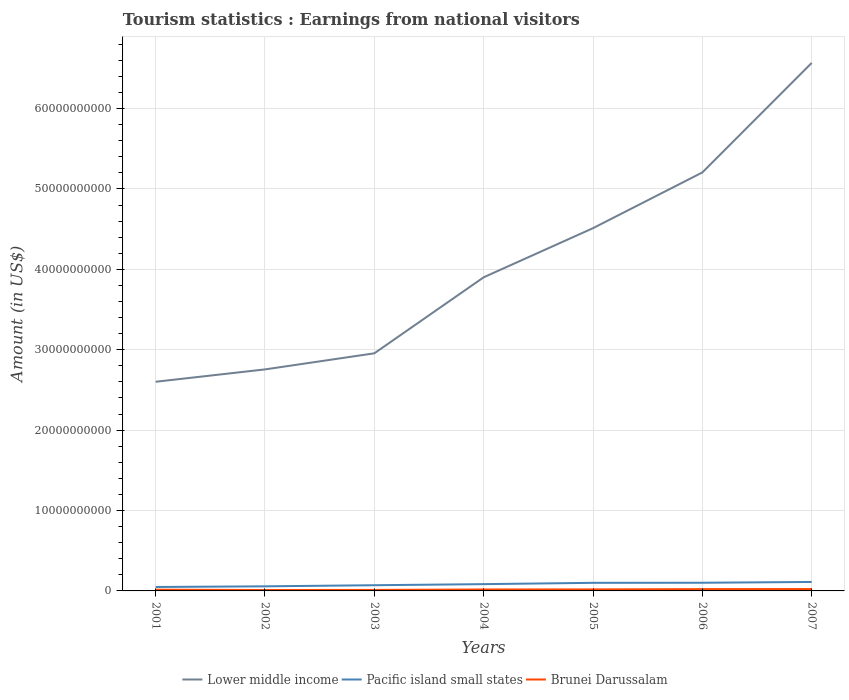How many different coloured lines are there?
Your answer should be compact. 3. Is the number of lines equal to the number of legend labels?
Keep it short and to the point. Yes. Across all years, what is the maximum earnings from national visitors in Brunei Darussalam?
Make the answer very short. 1.13e+08. In which year was the earnings from national visitors in Brunei Darussalam maximum?
Offer a terse response. 2002. What is the total earnings from national visitors in Lower middle income in the graph?
Offer a very short reply. -2.06e+1. What is the difference between the highest and the second highest earnings from national visitors in Lower middle income?
Your response must be concise. 3.97e+1. Is the earnings from national visitors in Lower middle income strictly greater than the earnings from national visitors in Pacific island small states over the years?
Your answer should be compact. No. How many years are there in the graph?
Your answer should be compact. 7. What is the difference between two consecutive major ticks on the Y-axis?
Make the answer very short. 1.00e+1. Are the values on the major ticks of Y-axis written in scientific E-notation?
Make the answer very short. No. Does the graph contain any zero values?
Provide a short and direct response. No. How many legend labels are there?
Make the answer very short. 3. What is the title of the graph?
Your answer should be very brief. Tourism statistics : Earnings from national visitors. What is the label or title of the Y-axis?
Give a very brief answer. Amount (in US$). What is the Amount (in US$) of Lower middle income in 2001?
Ensure brevity in your answer.  2.60e+1. What is the Amount (in US$) in Pacific island small states in 2001?
Offer a terse response. 4.90e+08. What is the Amount (in US$) in Brunei Darussalam in 2001?
Give a very brief answer. 1.55e+08. What is the Amount (in US$) of Lower middle income in 2002?
Offer a very short reply. 2.76e+1. What is the Amount (in US$) of Pacific island small states in 2002?
Your response must be concise. 5.71e+08. What is the Amount (in US$) in Brunei Darussalam in 2002?
Offer a very short reply. 1.13e+08. What is the Amount (in US$) in Lower middle income in 2003?
Give a very brief answer. 2.96e+1. What is the Amount (in US$) in Pacific island small states in 2003?
Your answer should be compact. 7.10e+08. What is the Amount (in US$) of Brunei Darussalam in 2003?
Provide a short and direct response. 1.24e+08. What is the Amount (in US$) in Lower middle income in 2004?
Provide a short and direct response. 3.90e+1. What is the Amount (in US$) of Pacific island small states in 2004?
Offer a terse response. 8.44e+08. What is the Amount (in US$) of Brunei Darussalam in 2004?
Give a very brief answer. 1.81e+08. What is the Amount (in US$) in Lower middle income in 2005?
Ensure brevity in your answer.  4.51e+1. What is the Amount (in US$) of Pacific island small states in 2005?
Your answer should be very brief. 1.01e+09. What is the Amount (in US$) of Brunei Darussalam in 2005?
Offer a terse response. 1.91e+08. What is the Amount (in US$) of Lower middle income in 2006?
Your answer should be very brief. 5.21e+1. What is the Amount (in US$) of Pacific island small states in 2006?
Your answer should be very brief. 1.02e+09. What is the Amount (in US$) in Brunei Darussalam in 2006?
Make the answer very short. 2.24e+08. What is the Amount (in US$) in Lower middle income in 2007?
Keep it short and to the point. 6.57e+1. What is the Amount (in US$) in Pacific island small states in 2007?
Your response must be concise. 1.12e+09. What is the Amount (in US$) of Brunei Darussalam in 2007?
Keep it short and to the point. 2.33e+08. Across all years, what is the maximum Amount (in US$) of Lower middle income?
Make the answer very short. 6.57e+1. Across all years, what is the maximum Amount (in US$) of Pacific island small states?
Provide a succinct answer. 1.12e+09. Across all years, what is the maximum Amount (in US$) in Brunei Darussalam?
Your response must be concise. 2.33e+08. Across all years, what is the minimum Amount (in US$) of Lower middle income?
Keep it short and to the point. 2.60e+1. Across all years, what is the minimum Amount (in US$) of Pacific island small states?
Provide a succinct answer. 4.90e+08. Across all years, what is the minimum Amount (in US$) of Brunei Darussalam?
Keep it short and to the point. 1.13e+08. What is the total Amount (in US$) of Lower middle income in the graph?
Your response must be concise. 2.85e+11. What is the total Amount (in US$) of Pacific island small states in the graph?
Your response must be concise. 5.75e+09. What is the total Amount (in US$) in Brunei Darussalam in the graph?
Provide a short and direct response. 1.22e+09. What is the difference between the Amount (in US$) in Lower middle income in 2001 and that in 2002?
Provide a succinct answer. -1.54e+09. What is the difference between the Amount (in US$) in Pacific island small states in 2001 and that in 2002?
Provide a succinct answer. -8.07e+07. What is the difference between the Amount (in US$) of Brunei Darussalam in 2001 and that in 2002?
Provide a short and direct response. 4.20e+07. What is the difference between the Amount (in US$) in Lower middle income in 2001 and that in 2003?
Your answer should be very brief. -3.54e+09. What is the difference between the Amount (in US$) of Pacific island small states in 2001 and that in 2003?
Offer a terse response. -2.20e+08. What is the difference between the Amount (in US$) of Brunei Darussalam in 2001 and that in 2003?
Offer a very short reply. 3.10e+07. What is the difference between the Amount (in US$) of Lower middle income in 2001 and that in 2004?
Provide a short and direct response. -1.30e+1. What is the difference between the Amount (in US$) in Pacific island small states in 2001 and that in 2004?
Provide a succinct answer. -3.54e+08. What is the difference between the Amount (in US$) of Brunei Darussalam in 2001 and that in 2004?
Provide a short and direct response. -2.60e+07. What is the difference between the Amount (in US$) in Lower middle income in 2001 and that in 2005?
Your response must be concise. -1.91e+1. What is the difference between the Amount (in US$) of Pacific island small states in 2001 and that in 2005?
Offer a terse response. -5.17e+08. What is the difference between the Amount (in US$) of Brunei Darussalam in 2001 and that in 2005?
Provide a short and direct response. -3.60e+07. What is the difference between the Amount (in US$) in Lower middle income in 2001 and that in 2006?
Give a very brief answer. -2.60e+1. What is the difference between the Amount (in US$) of Pacific island small states in 2001 and that in 2006?
Make the answer very short. -5.27e+08. What is the difference between the Amount (in US$) in Brunei Darussalam in 2001 and that in 2006?
Give a very brief answer. -6.90e+07. What is the difference between the Amount (in US$) of Lower middle income in 2001 and that in 2007?
Provide a short and direct response. -3.97e+1. What is the difference between the Amount (in US$) of Pacific island small states in 2001 and that in 2007?
Provide a short and direct response. -6.26e+08. What is the difference between the Amount (in US$) in Brunei Darussalam in 2001 and that in 2007?
Offer a terse response. -7.80e+07. What is the difference between the Amount (in US$) in Lower middle income in 2002 and that in 2003?
Make the answer very short. -2.00e+09. What is the difference between the Amount (in US$) of Pacific island small states in 2002 and that in 2003?
Your response must be concise. -1.39e+08. What is the difference between the Amount (in US$) of Brunei Darussalam in 2002 and that in 2003?
Provide a short and direct response. -1.10e+07. What is the difference between the Amount (in US$) of Lower middle income in 2002 and that in 2004?
Your answer should be compact. -1.15e+1. What is the difference between the Amount (in US$) of Pacific island small states in 2002 and that in 2004?
Give a very brief answer. -2.74e+08. What is the difference between the Amount (in US$) in Brunei Darussalam in 2002 and that in 2004?
Your response must be concise. -6.80e+07. What is the difference between the Amount (in US$) of Lower middle income in 2002 and that in 2005?
Your answer should be compact. -1.76e+1. What is the difference between the Amount (in US$) in Pacific island small states in 2002 and that in 2005?
Your answer should be very brief. -4.37e+08. What is the difference between the Amount (in US$) in Brunei Darussalam in 2002 and that in 2005?
Your answer should be very brief. -7.80e+07. What is the difference between the Amount (in US$) of Lower middle income in 2002 and that in 2006?
Provide a succinct answer. -2.45e+1. What is the difference between the Amount (in US$) in Pacific island small states in 2002 and that in 2006?
Your answer should be very brief. -4.46e+08. What is the difference between the Amount (in US$) of Brunei Darussalam in 2002 and that in 2006?
Your response must be concise. -1.11e+08. What is the difference between the Amount (in US$) of Lower middle income in 2002 and that in 2007?
Keep it short and to the point. -3.81e+1. What is the difference between the Amount (in US$) of Pacific island small states in 2002 and that in 2007?
Provide a short and direct response. -5.45e+08. What is the difference between the Amount (in US$) of Brunei Darussalam in 2002 and that in 2007?
Ensure brevity in your answer.  -1.20e+08. What is the difference between the Amount (in US$) of Lower middle income in 2003 and that in 2004?
Keep it short and to the point. -9.46e+09. What is the difference between the Amount (in US$) of Pacific island small states in 2003 and that in 2004?
Offer a very short reply. -1.34e+08. What is the difference between the Amount (in US$) of Brunei Darussalam in 2003 and that in 2004?
Your answer should be compact. -5.70e+07. What is the difference between the Amount (in US$) of Lower middle income in 2003 and that in 2005?
Your answer should be very brief. -1.56e+1. What is the difference between the Amount (in US$) of Pacific island small states in 2003 and that in 2005?
Keep it short and to the point. -2.97e+08. What is the difference between the Amount (in US$) in Brunei Darussalam in 2003 and that in 2005?
Offer a terse response. -6.70e+07. What is the difference between the Amount (in US$) in Lower middle income in 2003 and that in 2006?
Ensure brevity in your answer.  -2.25e+1. What is the difference between the Amount (in US$) in Pacific island small states in 2003 and that in 2006?
Offer a very short reply. -3.07e+08. What is the difference between the Amount (in US$) in Brunei Darussalam in 2003 and that in 2006?
Provide a short and direct response. -1.00e+08. What is the difference between the Amount (in US$) of Lower middle income in 2003 and that in 2007?
Give a very brief answer. -3.61e+1. What is the difference between the Amount (in US$) of Pacific island small states in 2003 and that in 2007?
Your answer should be compact. -4.06e+08. What is the difference between the Amount (in US$) of Brunei Darussalam in 2003 and that in 2007?
Keep it short and to the point. -1.09e+08. What is the difference between the Amount (in US$) in Lower middle income in 2004 and that in 2005?
Give a very brief answer. -6.11e+09. What is the difference between the Amount (in US$) of Pacific island small states in 2004 and that in 2005?
Your response must be concise. -1.63e+08. What is the difference between the Amount (in US$) of Brunei Darussalam in 2004 and that in 2005?
Your response must be concise. -1.00e+07. What is the difference between the Amount (in US$) of Lower middle income in 2004 and that in 2006?
Your response must be concise. -1.30e+1. What is the difference between the Amount (in US$) of Pacific island small states in 2004 and that in 2006?
Provide a succinct answer. -1.73e+08. What is the difference between the Amount (in US$) in Brunei Darussalam in 2004 and that in 2006?
Your answer should be compact. -4.30e+07. What is the difference between the Amount (in US$) in Lower middle income in 2004 and that in 2007?
Keep it short and to the point. -2.67e+1. What is the difference between the Amount (in US$) in Pacific island small states in 2004 and that in 2007?
Your answer should be compact. -2.71e+08. What is the difference between the Amount (in US$) of Brunei Darussalam in 2004 and that in 2007?
Offer a terse response. -5.20e+07. What is the difference between the Amount (in US$) of Lower middle income in 2005 and that in 2006?
Offer a terse response. -6.93e+09. What is the difference between the Amount (in US$) in Pacific island small states in 2005 and that in 2006?
Provide a succinct answer. -9.77e+06. What is the difference between the Amount (in US$) in Brunei Darussalam in 2005 and that in 2006?
Give a very brief answer. -3.30e+07. What is the difference between the Amount (in US$) of Lower middle income in 2005 and that in 2007?
Offer a very short reply. -2.06e+1. What is the difference between the Amount (in US$) in Pacific island small states in 2005 and that in 2007?
Offer a terse response. -1.08e+08. What is the difference between the Amount (in US$) in Brunei Darussalam in 2005 and that in 2007?
Offer a terse response. -4.20e+07. What is the difference between the Amount (in US$) in Lower middle income in 2006 and that in 2007?
Make the answer very short. -1.36e+1. What is the difference between the Amount (in US$) of Pacific island small states in 2006 and that in 2007?
Offer a very short reply. -9.85e+07. What is the difference between the Amount (in US$) of Brunei Darussalam in 2006 and that in 2007?
Offer a very short reply. -9.00e+06. What is the difference between the Amount (in US$) in Lower middle income in 2001 and the Amount (in US$) in Pacific island small states in 2002?
Your answer should be compact. 2.54e+1. What is the difference between the Amount (in US$) in Lower middle income in 2001 and the Amount (in US$) in Brunei Darussalam in 2002?
Ensure brevity in your answer.  2.59e+1. What is the difference between the Amount (in US$) in Pacific island small states in 2001 and the Amount (in US$) in Brunei Darussalam in 2002?
Your response must be concise. 3.77e+08. What is the difference between the Amount (in US$) in Lower middle income in 2001 and the Amount (in US$) in Pacific island small states in 2003?
Give a very brief answer. 2.53e+1. What is the difference between the Amount (in US$) of Lower middle income in 2001 and the Amount (in US$) of Brunei Darussalam in 2003?
Provide a short and direct response. 2.59e+1. What is the difference between the Amount (in US$) in Pacific island small states in 2001 and the Amount (in US$) in Brunei Darussalam in 2003?
Your answer should be compact. 3.66e+08. What is the difference between the Amount (in US$) of Lower middle income in 2001 and the Amount (in US$) of Pacific island small states in 2004?
Your answer should be compact. 2.52e+1. What is the difference between the Amount (in US$) of Lower middle income in 2001 and the Amount (in US$) of Brunei Darussalam in 2004?
Provide a short and direct response. 2.58e+1. What is the difference between the Amount (in US$) of Pacific island small states in 2001 and the Amount (in US$) of Brunei Darussalam in 2004?
Your response must be concise. 3.09e+08. What is the difference between the Amount (in US$) in Lower middle income in 2001 and the Amount (in US$) in Pacific island small states in 2005?
Keep it short and to the point. 2.50e+1. What is the difference between the Amount (in US$) of Lower middle income in 2001 and the Amount (in US$) of Brunei Darussalam in 2005?
Make the answer very short. 2.58e+1. What is the difference between the Amount (in US$) in Pacific island small states in 2001 and the Amount (in US$) in Brunei Darussalam in 2005?
Provide a short and direct response. 2.99e+08. What is the difference between the Amount (in US$) in Lower middle income in 2001 and the Amount (in US$) in Pacific island small states in 2006?
Offer a terse response. 2.50e+1. What is the difference between the Amount (in US$) in Lower middle income in 2001 and the Amount (in US$) in Brunei Darussalam in 2006?
Keep it short and to the point. 2.58e+1. What is the difference between the Amount (in US$) of Pacific island small states in 2001 and the Amount (in US$) of Brunei Darussalam in 2006?
Your response must be concise. 2.66e+08. What is the difference between the Amount (in US$) of Lower middle income in 2001 and the Amount (in US$) of Pacific island small states in 2007?
Offer a very short reply. 2.49e+1. What is the difference between the Amount (in US$) of Lower middle income in 2001 and the Amount (in US$) of Brunei Darussalam in 2007?
Your answer should be very brief. 2.58e+1. What is the difference between the Amount (in US$) in Pacific island small states in 2001 and the Amount (in US$) in Brunei Darussalam in 2007?
Offer a very short reply. 2.57e+08. What is the difference between the Amount (in US$) in Lower middle income in 2002 and the Amount (in US$) in Pacific island small states in 2003?
Ensure brevity in your answer.  2.68e+1. What is the difference between the Amount (in US$) in Lower middle income in 2002 and the Amount (in US$) in Brunei Darussalam in 2003?
Make the answer very short. 2.74e+1. What is the difference between the Amount (in US$) in Pacific island small states in 2002 and the Amount (in US$) in Brunei Darussalam in 2003?
Offer a very short reply. 4.47e+08. What is the difference between the Amount (in US$) in Lower middle income in 2002 and the Amount (in US$) in Pacific island small states in 2004?
Your response must be concise. 2.67e+1. What is the difference between the Amount (in US$) in Lower middle income in 2002 and the Amount (in US$) in Brunei Darussalam in 2004?
Your answer should be compact. 2.74e+1. What is the difference between the Amount (in US$) in Pacific island small states in 2002 and the Amount (in US$) in Brunei Darussalam in 2004?
Your answer should be very brief. 3.90e+08. What is the difference between the Amount (in US$) of Lower middle income in 2002 and the Amount (in US$) of Pacific island small states in 2005?
Provide a succinct answer. 2.65e+1. What is the difference between the Amount (in US$) in Lower middle income in 2002 and the Amount (in US$) in Brunei Darussalam in 2005?
Keep it short and to the point. 2.74e+1. What is the difference between the Amount (in US$) in Pacific island small states in 2002 and the Amount (in US$) in Brunei Darussalam in 2005?
Your answer should be very brief. 3.80e+08. What is the difference between the Amount (in US$) of Lower middle income in 2002 and the Amount (in US$) of Pacific island small states in 2006?
Your answer should be compact. 2.65e+1. What is the difference between the Amount (in US$) of Lower middle income in 2002 and the Amount (in US$) of Brunei Darussalam in 2006?
Offer a very short reply. 2.73e+1. What is the difference between the Amount (in US$) in Pacific island small states in 2002 and the Amount (in US$) in Brunei Darussalam in 2006?
Offer a terse response. 3.47e+08. What is the difference between the Amount (in US$) of Lower middle income in 2002 and the Amount (in US$) of Pacific island small states in 2007?
Offer a very short reply. 2.64e+1. What is the difference between the Amount (in US$) in Lower middle income in 2002 and the Amount (in US$) in Brunei Darussalam in 2007?
Make the answer very short. 2.73e+1. What is the difference between the Amount (in US$) of Pacific island small states in 2002 and the Amount (in US$) of Brunei Darussalam in 2007?
Give a very brief answer. 3.38e+08. What is the difference between the Amount (in US$) in Lower middle income in 2003 and the Amount (in US$) in Pacific island small states in 2004?
Your response must be concise. 2.87e+1. What is the difference between the Amount (in US$) in Lower middle income in 2003 and the Amount (in US$) in Brunei Darussalam in 2004?
Your response must be concise. 2.94e+1. What is the difference between the Amount (in US$) in Pacific island small states in 2003 and the Amount (in US$) in Brunei Darussalam in 2004?
Make the answer very short. 5.29e+08. What is the difference between the Amount (in US$) of Lower middle income in 2003 and the Amount (in US$) of Pacific island small states in 2005?
Your answer should be compact. 2.85e+1. What is the difference between the Amount (in US$) of Lower middle income in 2003 and the Amount (in US$) of Brunei Darussalam in 2005?
Your answer should be compact. 2.94e+1. What is the difference between the Amount (in US$) of Pacific island small states in 2003 and the Amount (in US$) of Brunei Darussalam in 2005?
Offer a very short reply. 5.19e+08. What is the difference between the Amount (in US$) in Lower middle income in 2003 and the Amount (in US$) in Pacific island small states in 2006?
Your answer should be very brief. 2.85e+1. What is the difference between the Amount (in US$) of Lower middle income in 2003 and the Amount (in US$) of Brunei Darussalam in 2006?
Keep it short and to the point. 2.93e+1. What is the difference between the Amount (in US$) of Pacific island small states in 2003 and the Amount (in US$) of Brunei Darussalam in 2006?
Your answer should be compact. 4.86e+08. What is the difference between the Amount (in US$) in Lower middle income in 2003 and the Amount (in US$) in Pacific island small states in 2007?
Ensure brevity in your answer.  2.84e+1. What is the difference between the Amount (in US$) in Lower middle income in 2003 and the Amount (in US$) in Brunei Darussalam in 2007?
Offer a very short reply. 2.93e+1. What is the difference between the Amount (in US$) of Pacific island small states in 2003 and the Amount (in US$) of Brunei Darussalam in 2007?
Provide a short and direct response. 4.77e+08. What is the difference between the Amount (in US$) of Lower middle income in 2004 and the Amount (in US$) of Pacific island small states in 2005?
Your answer should be compact. 3.80e+1. What is the difference between the Amount (in US$) of Lower middle income in 2004 and the Amount (in US$) of Brunei Darussalam in 2005?
Give a very brief answer. 3.88e+1. What is the difference between the Amount (in US$) in Pacific island small states in 2004 and the Amount (in US$) in Brunei Darussalam in 2005?
Offer a very short reply. 6.53e+08. What is the difference between the Amount (in US$) of Lower middle income in 2004 and the Amount (in US$) of Pacific island small states in 2006?
Offer a terse response. 3.80e+1. What is the difference between the Amount (in US$) in Lower middle income in 2004 and the Amount (in US$) in Brunei Darussalam in 2006?
Make the answer very short. 3.88e+1. What is the difference between the Amount (in US$) in Pacific island small states in 2004 and the Amount (in US$) in Brunei Darussalam in 2006?
Provide a succinct answer. 6.20e+08. What is the difference between the Amount (in US$) in Lower middle income in 2004 and the Amount (in US$) in Pacific island small states in 2007?
Ensure brevity in your answer.  3.79e+1. What is the difference between the Amount (in US$) in Lower middle income in 2004 and the Amount (in US$) in Brunei Darussalam in 2007?
Offer a terse response. 3.88e+1. What is the difference between the Amount (in US$) in Pacific island small states in 2004 and the Amount (in US$) in Brunei Darussalam in 2007?
Your response must be concise. 6.11e+08. What is the difference between the Amount (in US$) of Lower middle income in 2005 and the Amount (in US$) of Pacific island small states in 2006?
Make the answer very short. 4.41e+1. What is the difference between the Amount (in US$) in Lower middle income in 2005 and the Amount (in US$) in Brunei Darussalam in 2006?
Your answer should be very brief. 4.49e+1. What is the difference between the Amount (in US$) of Pacific island small states in 2005 and the Amount (in US$) of Brunei Darussalam in 2006?
Provide a succinct answer. 7.83e+08. What is the difference between the Amount (in US$) of Lower middle income in 2005 and the Amount (in US$) of Pacific island small states in 2007?
Keep it short and to the point. 4.40e+1. What is the difference between the Amount (in US$) of Lower middle income in 2005 and the Amount (in US$) of Brunei Darussalam in 2007?
Your response must be concise. 4.49e+1. What is the difference between the Amount (in US$) in Pacific island small states in 2005 and the Amount (in US$) in Brunei Darussalam in 2007?
Your answer should be very brief. 7.74e+08. What is the difference between the Amount (in US$) of Lower middle income in 2006 and the Amount (in US$) of Pacific island small states in 2007?
Provide a short and direct response. 5.09e+1. What is the difference between the Amount (in US$) of Lower middle income in 2006 and the Amount (in US$) of Brunei Darussalam in 2007?
Ensure brevity in your answer.  5.18e+1. What is the difference between the Amount (in US$) of Pacific island small states in 2006 and the Amount (in US$) of Brunei Darussalam in 2007?
Give a very brief answer. 7.84e+08. What is the average Amount (in US$) in Lower middle income per year?
Give a very brief answer. 4.07e+1. What is the average Amount (in US$) in Pacific island small states per year?
Your response must be concise. 8.22e+08. What is the average Amount (in US$) in Brunei Darussalam per year?
Your answer should be very brief. 1.74e+08. In the year 2001, what is the difference between the Amount (in US$) in Lower middle income and Amount (in US$) in Pacific island small states?
Make the answer very short. 2.55e+1. In the year 2001, what is the difference between the Amount (in US$) in Lower middle income and Amount (in US$) in Brunei Darussalam?
Provide a succinct answer. 2.59e+1. In the year 2001, what is the difference between the Amount (in US$) of Pacific island small states and Amount (in US$) of Brunei Darussalam?
Your answer should be compact. 3.35e+08. In the year 2002, what is the difference between the Amount (in US$) of Lower middle income and Amount (in US$) of Pacific island small states?
Offer a terse response. 2.70e+1. In the year 2002, what is the difference between the Amount (in US$) in Lower middle income and Amount (in US$) in Brunei Darussalam?
Keep it short and to the point. 2.74e+1. In the year 2002, what is the difference between the Amount (in US$) in Pacific island small states and Amount (in US$) in Brunei Darussalam?
Ensure brevity in your answer.  4.58e+08. In the year 2003, what is the difference between the Amount (in US$) in Lower middle income and Amount (in US$) in Pacific island small states?
Ensure brevity in your answer.  2.88e+1. In the year 2003, what is the difference between the Amount (in US$) of Lower middle income and Amount (in US$) of Brunei Darussalam?
Your answer should be very brief. 2.94e+1. In the year 2003, what is the difference between the Amount (in US$) in Pacific island small states and Amount (in US$) in Brunei Darussalam?
Give a very brief answer. 5.86e+08. In the year 2004, what is the difference between the Amount (in US$) of Lower middle income and Amount (in US$) of Pacific island small states?
Offer a terse response. 3.82e+1. In the year 2004, what is the difference between the Amount (in US$) of Lower middle income and Amount (in US$) of Brunei Darussalam?
Offer a very short reply. 3.88e+1. In the year 2004, what is the difference between the Amount (in US$) in Pacific island small states and Amount (in US$) in Brunei Darussalam?
Offer a very short reply. 6.63e+08. In the year 2005, what is the difference between the Amount (in US$) in Lower middle income and Amount (in US$) in Pacific island small states?
Make the answer very short. 4.41e+1. In the year 2005, what is the difference between the Amount (in US$) in Lower middle income and Amount (in US$) in Brunei Darussalam?
Give a very brief answer. 4.49e+1. In the year 2005, what is the difference between the Amount (in US$) of Pacific island small states and Amount (in US$) of Brunei Darussalam?
Your response must be concise. 8.16e+08. In the year 2006, what is the difference between the Amount (in US$) of Lower middle income and Amount (in US$) of Pacific island small states?
Make the answer very short. 5.10e+1. In the year 2006, what is the difference between the Amount (in US$) in Lower middle income and Amount (in US$) in Brunei Darussalam?
Your answer should be compact. 5.18e+1. In the year 2006, what is the difference between the Amount (in US$) of Pacific island small states and Amount (in US$) of Brunei Darussalam?
Ensure brevity in your answer.  7.93e+08. In the year 2007, what is the difference between the Amount (in US$) of Lower middle income and Amount (in US$) of Pacific island small states?
Your answer should be compact. 6.46e+1. In the year 2007, what is the difference between the Amount (in US$) of Lower middle income and Amount (in US$) of Brunei Darussalam?
Provide a succinct answer. 6.54e+1. In the year 2007, what is the difference between the Amount (in US$) of Pacific island small states and Amount (in US$) of Brunei Darussalam?
Make the answer very short. 8.82e+08. What is the ratio of the Amount (in US$) of Lower middle income in 2001 to that in 2002?
Provide a short and direct response. 0.94. What is the ratio of the Amount (in US$) in Pacific island small states in 2001 to that in 2002?
Keep it short and to the point. 0.86. What is the ratio of the Amount (in US$) in Brunei Darussalam in 2001 to that in 2002?
Offer a very short reply. 1.37. What is the ratio of the Amount (in US$) of Lower middle income in 2001 to that in 2003?
Your answer should be very brief. 0.88. What is the ratio of the Amount (in US$) in Pacific island small states in 2001 to that in 2003?
Your answer should be very brief. 0.69. What is the ratio of the Amount (in US$) in Lower middle income in 2001 to that in 2004?
Make the answer very short. 0.67. What is the ratio of the Amount (in US$) of Pacific island small states in 2001 to that in 2004?
Offer a terse response. 0.58. What is the ratio of the Amount (in US$) in Brunei Darussalam in 2001 to that in 2004?
Your answer should be very brief. 0.86. What is the ratio of the Amount (in US$) in Lower middle income in 2001 to that in 2005?
Provide a short and direct response. 0.58. What is the ratio of the Amount (in US$) in Pacific island small states in 2001 to that in 2005?
Offer a terse response. 0.49. What is the ratio of the Amount (in US$) in Brunei Darussalam in 2001 to that in 2005?
Your answer should be very brief. 0.81. What is the ratio of the Amount (in US$) of Lower middle income in 2001 to that in 2006?
Your answer should be very brief. 0.5. What is the ratio of the Amount (in US$) in Pacific island small states in 2001 to that in 2006?
Keep it short and to the point. 0.48. What is the ratio of the Amount (in US$) in Brunei Darussalam in 2001 to that in 2006?
Make the answer very short. 0.69. What is the ratio of the Amount (in US$) in Lower middle income in 2001 to that in 2007?
Provide a short and direct response. 0.4. What is the ratio of the Amount (in US$) of Pacific island small states in 2001 to that in 2007?
Offer a terse response. 0.44. What is the ratio of the Amount (in US$) of Brunei Darussalam in 2001 to that in 2007?
Give a very brief answer. 0.67. What is the ratio of the Amount (in US$) of Lower middle income in 2002 to that in 2003?
Offer a terse response. 0.93. What is the ratio of the Amount (in US$) in Pacific island small states in 2002 to that in 2003?
Ensure brevity in your answer.  0.8. What is the ratio of the Amount (in US$) in Brunei Darussalam in 2002 to that in 2003?
Keep it short and to the point. 0.91. What is the ratio of the Amount (in US$) in Lower middle income in 2002 to that in 2004?
Provide a short and direct response. 0.71. What is the ratio of the Amount (in US$) in Pacific island small states in 2002 to that in 2004?
Offer a terse response. 0.68. What is the ratio of the Amount (in US$) of Brunei Darussalam in 2002 to that in 2004?
Provide a succinct answer. 0.62. What is the ratio of the Amount (in US$) in Lower middle income in 2002 to that in 2005?
Provide a short and direct response. 0.61. What is the ratio of the Amount (in US$) in Pacific island small states in 2002 to that in 2005?
Give a very brief answer. 0.57. What is the ratio of the Amount (in US$) of Brunei Darussalam in 2002 to that in 2005?
Your answer should be very brief. 0.59. What is the ratio of the Amount (in US$) of Lower middle income in 2002 to that in 2006?
Make the answer very short. 0.53. What is the ratio of the Amount (in US$) of Pacific island small states in 2002 to that in 2006?
Your answer should be compact. 0.56. What is the ratio of the Amount (in US$) of Brunei Darussalam in 2002 to that in 2006?
Make the answer very short. 0.5. What is the ratio of the Amount (in US$) in Lower middle income in 2002 to that in 2007?
Provide a short and direct response. 0.42. What is the ratio of the Amount (in US$) in Pacific island small states in 2002 to that in 2007?
Offer a very short reply. 0.51. What is the ratio of the Amount (in US$) in Brunei Darussalam in 2002 to that in 2007?
Provide a succinct answer. 0.48. What is the ratio of the Amount (in US$) of Lower middle income in 2003 to that in 2004?
Offer a very short reply. 0.76. What is the ratio of the Amount (in US$) of Pacific island small states in 2003 to that in 2004?
Provide a short and direct response. 0.84. What is the ratio of the Amount (in US$) of Brunei Darussalam in 2003 to that in 2004?
Offer a very short reply. 0.69. What is the ratio of the Amount (in US$) in Lower middle income in 2003 to that in 2005?
Your response must be concise. 0.66. What is the ratio of the Amount (in US$) of Pacific island small states in 2003 to that in 2005?
Offer a very short reply. 0.7. What is the ratio of the Amount (in US$) of Brunei Darussalam in 2003 to that in 2005?
Your answer should be very brief. 0.65. What is the ratio of the Amount (in US$) in Lower middle income in 2003 to that in 2006?
Offer a terse response. 0.57. What is the ratio of the Amount (in US$) of Pacific island small states in 2003 to that in 2006?
Keep it short and to the point. 0.7. What is the ratio of the Amount (in US$) in Brunei Darussalam in 2003 to that in 2006?
Give a very brief answer. 0.55. What is the ratio of the Amount (in US$) in Lower middle income in 2003 to that in 2007?
Keep it short and to the point. 0.45. What is the ratio of the Amount (in US$) of Pacific island small states in 2003 to that in 2007?
Make the answer very short. 0.64. What is the ratio of the Amount (in US$) of Brunei Darussalam in 2003 to that in 2007?
Provide a short and direct response. 0.53. What is the ratio of the Amount (in US$) of Lower middle income in 2004 to that in 2005?
Keep it short and to the point. 0.86. What is the ratio of the Amount (in US$) of Pacific island small states in 2004 to that in 2005?
Ensure brevity in your answer.  0.84. What is the ratio of the Amount (in US$) in Brunei Darussalam in 2004 to that in 2005?
Offer a very short reply. 0.95. What is the ratio of the Amount (in US$) of Lower middle income in 2004 to that in 2006?
Provide a succinct answer. 0.75. What is the ratio of the Amount (in US$) in Pacific island small states in 2004 to that in 2006?
Give a very brief answer. 0.83. What is the ratio of the Amount (in US$) of Brunei Darussalam in 2004 to that in 2006?
Offer a very short reply. 0.81. What is the ratio of the Amount (in US$) of Lower middle income in 2004 to that in 2007?
Give a very brief answer. 0.59. What is the ratio of the Amount (in US$) of Pacific island small states in 2004 to that in 2007?
Keep it short and to the point. 0.76. What is the ratio of the Amount (in US$) of Brunei Darussalam in 2004 to that in 2007?
Your response must be concise. 0.78. What is the ratio of the Amount (in US$) in Lower middle income in 2005 to that in 2006?
Provide a short and direct response. 0.87. What is the ratio of the Amount (in US$) of Pacific island small states in 2005 to that in 2006?
Your answer should be very brief. 0.99. What is the ratio of the Amount (in US$) in Brunei Darussalam in 2005 to that in 2006?
Give a very brief answer. 0.85. What is the ratio of the Amount (in US$) of Lower middle income in 2005 to that in 2007?
Offer a very short reply. 0.69. What is the ratio of the Amount (in US$) in Pacific island small states in 2005 to that in 2007?
Keep it short and to the point. 0.9. What is the ratio of the Amount (in US$) of Brunei Darussalam in 2005 to that in 2007?
Offer a very short reply. 0.82. What is the ratio of the Amount (in US$) of Lower middle income in 2006 to that in 2007?
Offer a very short reply. 0.79. What is the ratio of the Amount (in US$) of Pacific island small states in 2006 to that in 2007?
Ensure brevity in your answer.  0.91. What is the ratio of the Amount (in US$) in Brunei Darussalam in 2006 to that in 2007?
Make the answer very short. 0.96. What is the difference between the highest and the second highest Amount (in US$) in Lower middle income?
Offer a very short reply. 1.36e+1. What is the difference between the highest and the second highest Amount (in US$) of Pacific island small states?
Provide a short and direct response. 9.85e+07. What is the difference between the highest and the second highest Amount (in US$) in Brunei Darussalam?
Ensure brevity in your answer.  9.00e+06. What is the difference between the highest and the lowest Amount (in US$) in Lower middle income?
Ensure brevity in your answer.  3.97e+1. What is the difference between the highest and the lowest Amount (in US$) in Pacific island small states?
Offer a terse response. 6.26e+08. What is the difference between the highest and the lowest Amount (in US$) of Brunei Darussalam?
Keep it short and to the point. 1.20e+08. 